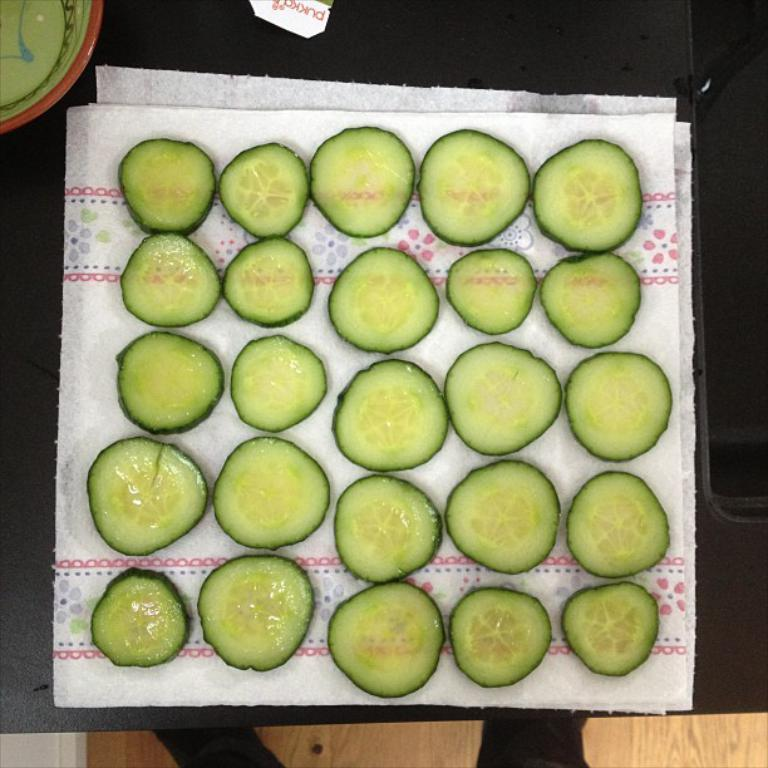What type of vegetable is present in the image? There are chopped cucumber in the image. How are the chopped cucumber arranged or placed? The chopped cucumber is on tissue paper. What type of rail can be seen in the image? There is no rail present in the image; it features chopped cucumber on tissue paper. How many quarters are visible in the image? There are no quarters present in the image. 